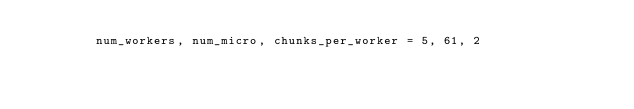<code> <loc_0><loc_0><loc_500><loc_500><_Python_>        num_workers, num_micro, chunks_per_worker = 5, 61, 2</code> 